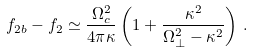<formula> <loc_0><loc_0><loc_500><loc_500>f _ { 2 b } - f _ { 2 } \simeq \frac { \Omega _ { c } ^ { 2 } } { 4 \pi \kappa } \left ( 1 + \frac { \kappa ^ { 2 } } { \Omega _ { \perp } ^ { 2 } - \kappa ^ { 2 } } \right ) \, .</formula> 